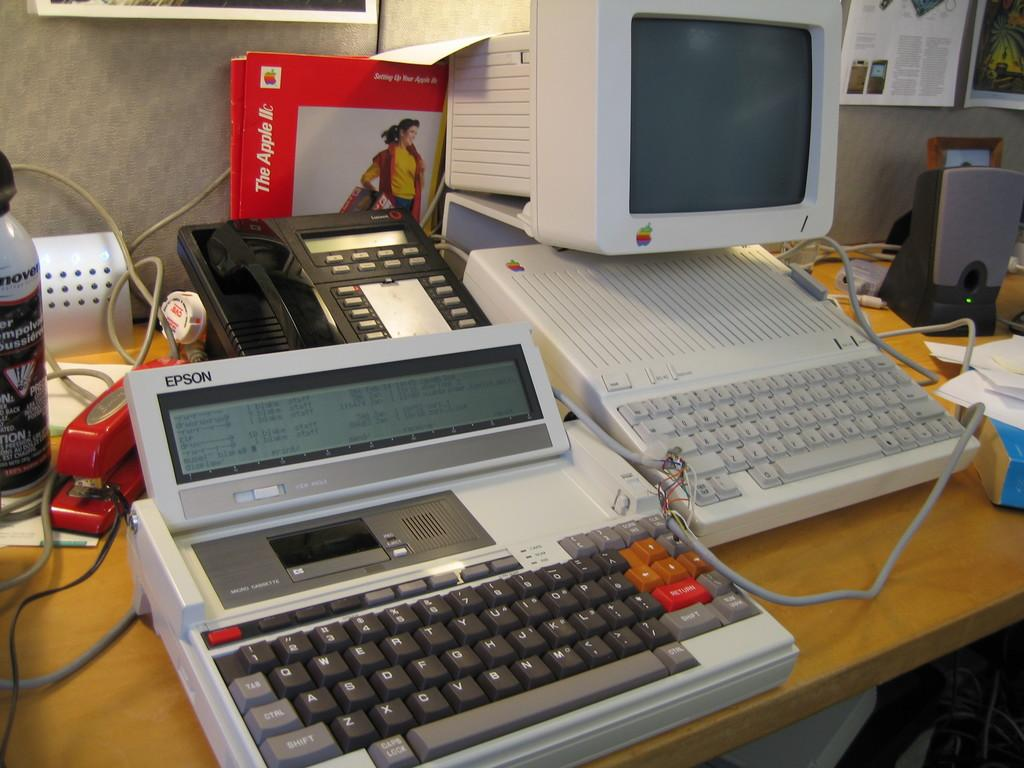What type of electronic device is visible in the image? There is a monitor in the image. What is used for input with the monitor? There is a keyboard in the image, which is used for input. Are there any additional input devices in the image? Yes, there is an additional keyboard in the image. What is used for audio output in the image? There is a speaker in the image for audio output. What connects the devices in the image? Cable wires are present in the image to connect the devices. What is the only non-electronic item visible in the image? There is a bottle in the image, which is the only non-electronic item. Where are all the mentioned items located in the image? All the mentioned items are placed on a table. How many pigs are visible in the image? There are no pigs present in the image. What type of pin is used to start the monitor in the image? The monitor in the image does not require a pin to start, and there is no pin mentioned in the provided facts. 